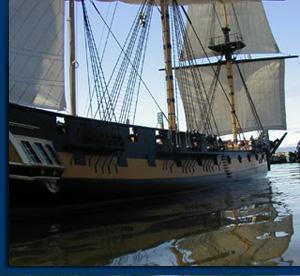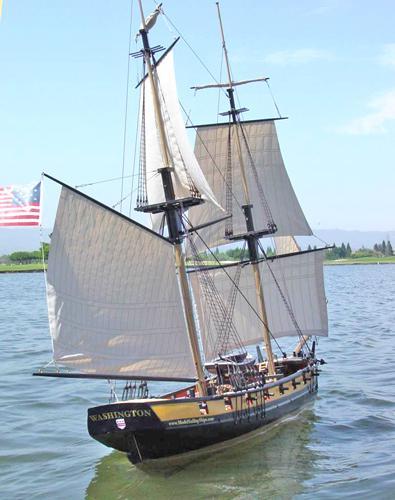The first image is the image on the left, the second image is the image on the right. For the images shown, is this caption "All sailing ships are floating on water." true? Answer yes or no. Yes. The first image is the image on the left, the second image is the image on the right. Assess this claim about the two images: "The boats in the image on the left are in the water.". Correct or not? Answer yes or no. Yes. 